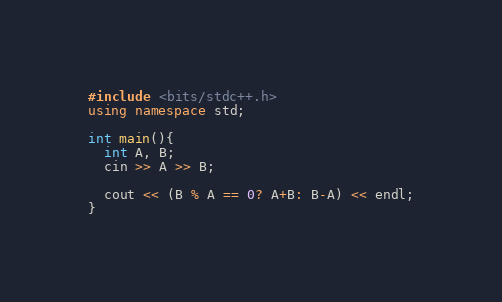<code> <loc_0><loc_0><loc_500><loc_500><_C++_>#include <bits/stdc++.h>
using namespace std;

int main(){
  int A, B;
  cin >> A >> B;
  
  cout << (B % A == 0? A+B: B-A) << endl;
}</code> 